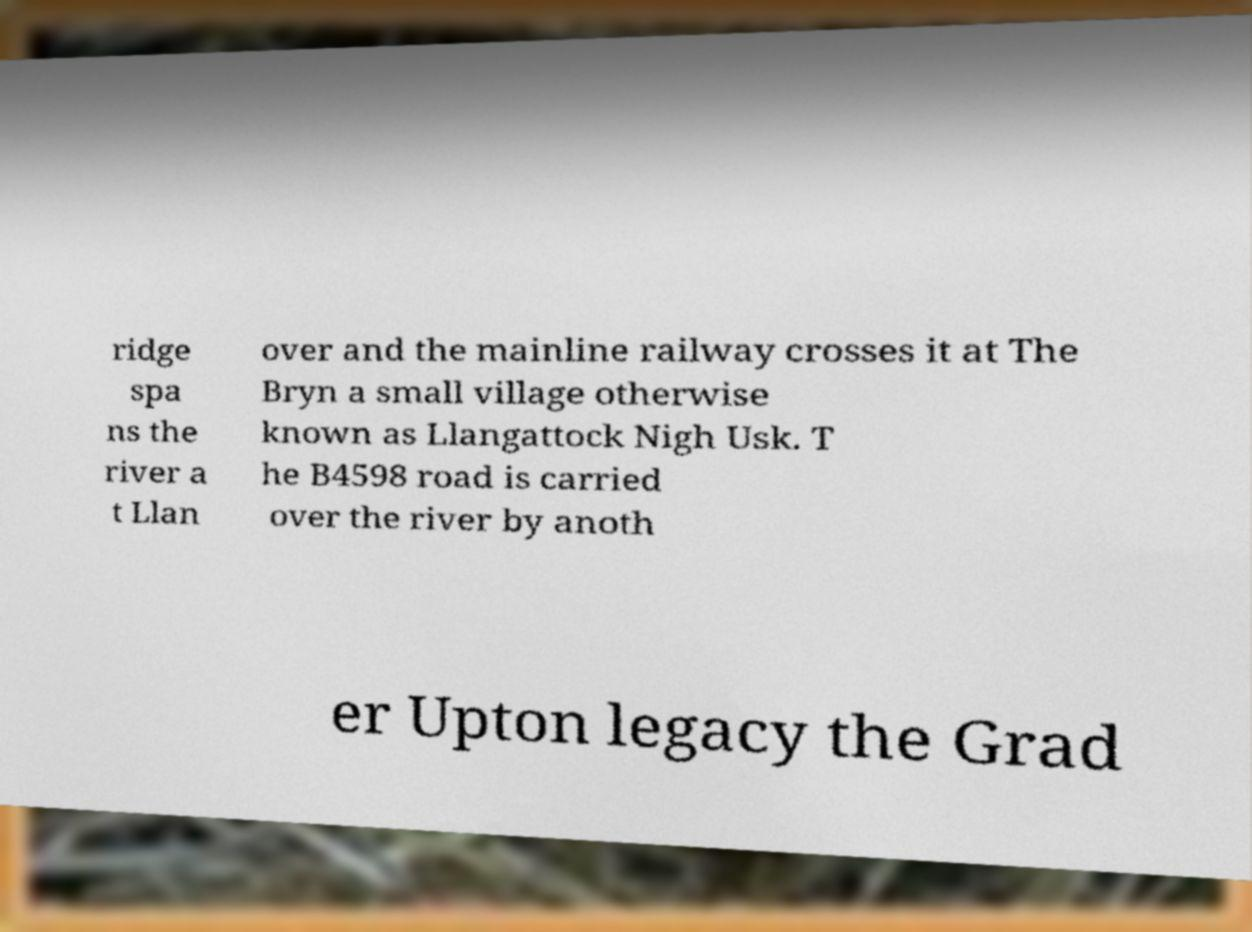There's text embedded in this image that I need extracted. Can you transcribe it verbatim? ridge spa ns the river a t Llan over and the mainline railway crosses it at The Bryn a small village otherwise known as Llangattock Nigh Usk. T he B4598 road is carried over the river by anoth er Upton legacy the Grad 